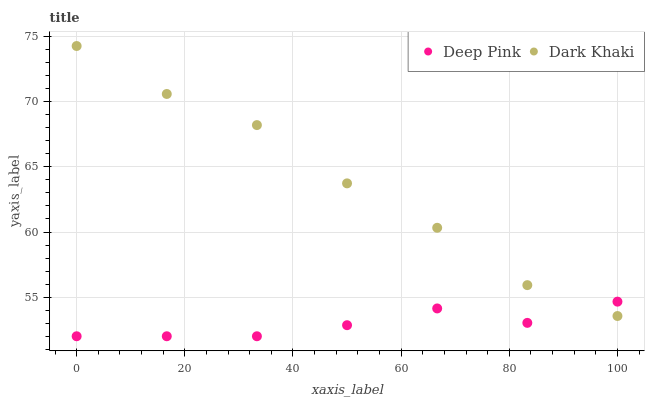Does Deep Pink have the minimum area under the curve?
Answer yes or no. Yes. Does Dark Khaki have the maximum area under the curve?
Answer yes or no. Yes. Does Deep Pink have the maximum area under the curve?
Answer yes or no. No. Is Deep Pink the smoothest?
Answer yes or no. Yes. Is Dark Khaki the roughest?
Answer yes or no. Yes. Is Deep Pink the roughest?
Answer yes or no. No. Does Deep Pink have the lowest value?
Answer yes or no. Yes. Does Dark Khaki have the highest value?
Answer yes or no. Yes. Does Deep Pink have the highest value?
Answer yes or no. No. Does Dark Khaki intersect Deep Pink?
Answer yes or no. Yes. Is Dark Khaki less than Deep Pink?
Answer yes or no. No. Is Dark Khaki greater than Deep Pink?
Answer yes or no. No. 